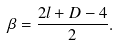<formula> <loc_0><loc_0><loc_500><loc_500>\beta = \frac { 2 l + D - 4 } { 2 } .</formula> 